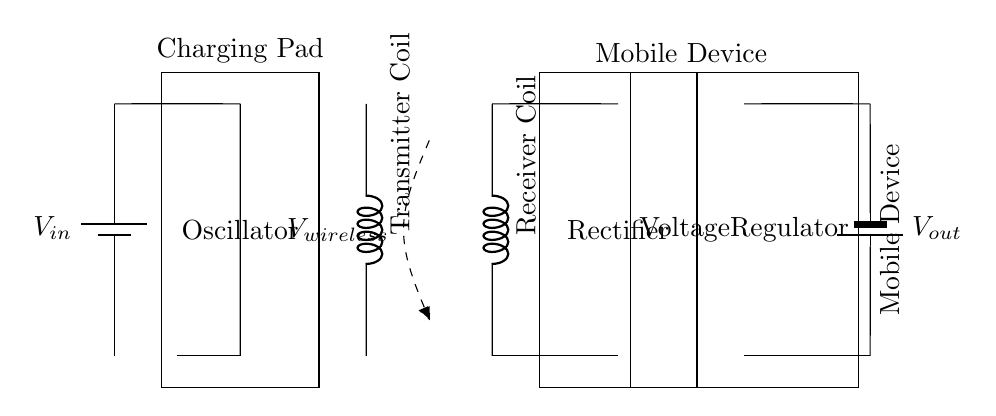What is the purpose of the oscillator in this circuit? The oscillator generates an alternating current, which is necessary for the operation of the wireless charging system. It converts the direct current from the input voltage source into an alternating signal that can induce a magnetic field.
Answer: Alternating current generation What components are used for wireless power transfer? The transmitter coil and the receiver coil are the components responsible for wireless power transfer by creating a magnetic field, which can induce voltage in the receiver coil.
Answer: Transmitter and receiver coils What does the rectifier do in this circuit? The rectifier converts the alternating current induced in the receiver coil back into direct current to charge the mobile device's battery. This conversion is essential for compatibility with the battery's charging requirements.
Answer: Converts AC to DC What voltage does the mobile device battery receive as output? The output voltage labeled as V out is the voltage supplied to the mobile device's battery after it has been regulated, which ensures it's suitable for charging without damaging the battery.
Answer: V out How does the wireless charging work in terms of coils? The transmitter coil creates a magnetic field when alternating current flows through it, and this field induces an alternating current in the receiver coil when the mobile device is placed on the charging pad, which is then rectified into direct current.
Answer: Induction through coils What does the voltage regulator do? The voltage regulator ensures that the output voltage to the mobile device's battery is stable and at the correct level, preventing fluctuations that could harm the battery.
Answer: Stabilizes output voltage What type of power source is indicated in this circuit? The power source connected to the system is a battery, indicated as V in, providing the initial direct current voltage required for the circuit's operation.
Answer: Battery 